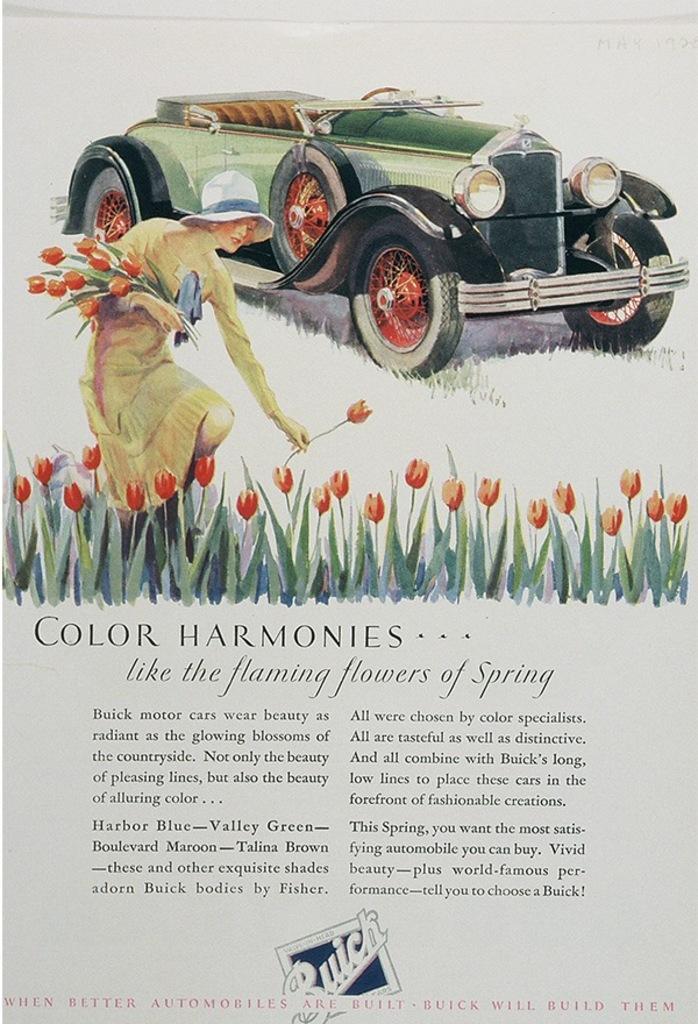Can you describe this image briefly? This is a poster having a painting, a logo and texts. In the painting, there is a woman wearing a cap and holding flowers. Beside her, there are plants having flowers. In the background, there is a vehicle on the ground, on which there is grass. 